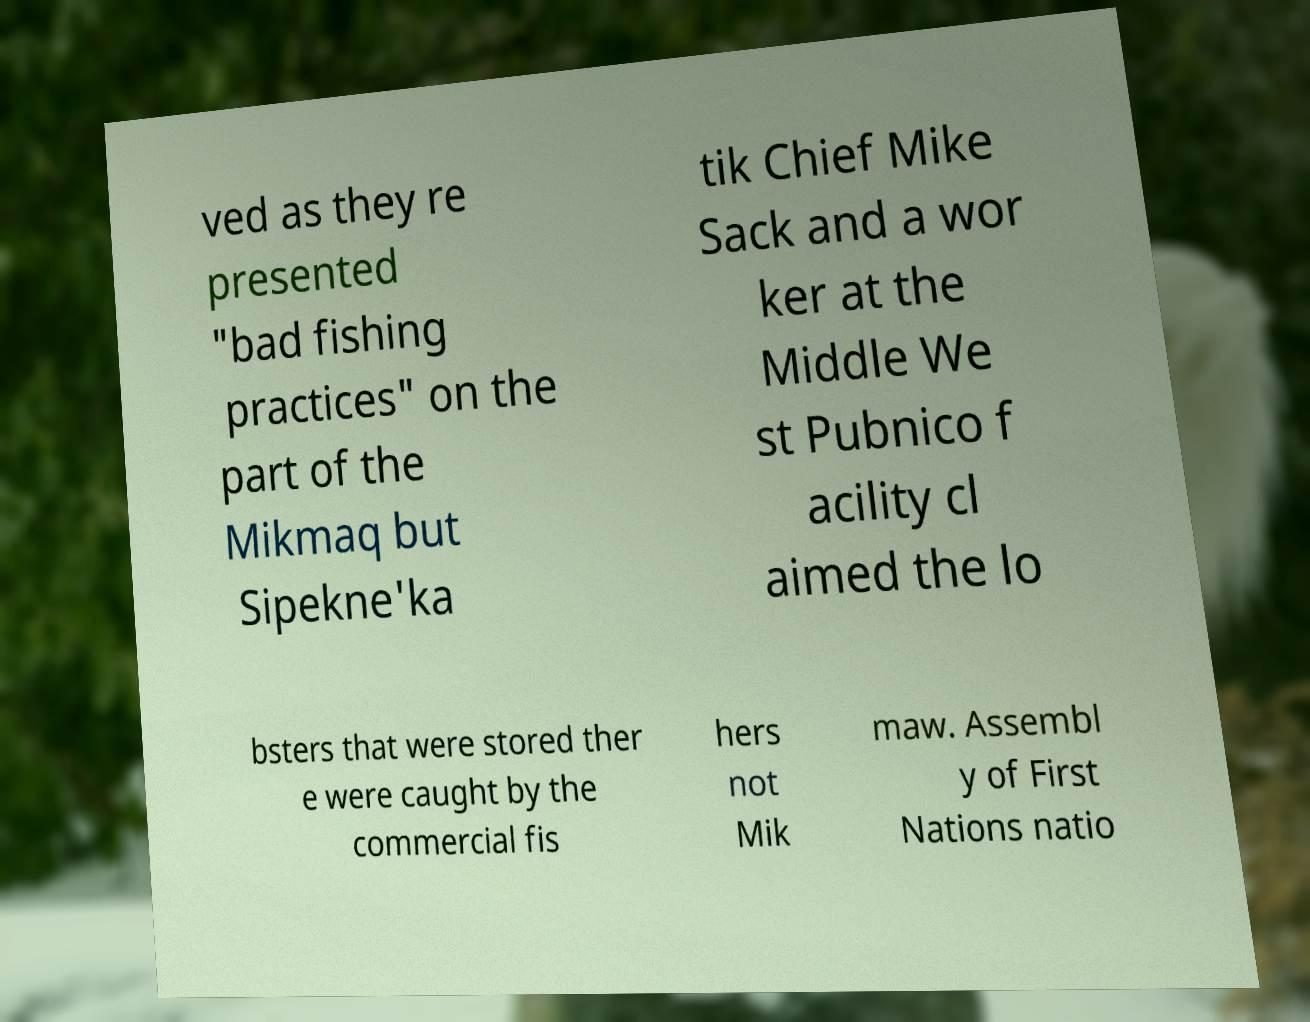Could you assist in decoding the text presented in this image and type it out clearly? ved as they re presented "bad fishing practices" on the part of the Mikmaq but Sipekne'ka tik Chief Mike Sack and a wor ker at the Middle We st Pubnico f acility cl aimed the lo bsters that were stored ther e were caught by the commercial fis hers not Mik maw. Assembl y of First Nations natio 